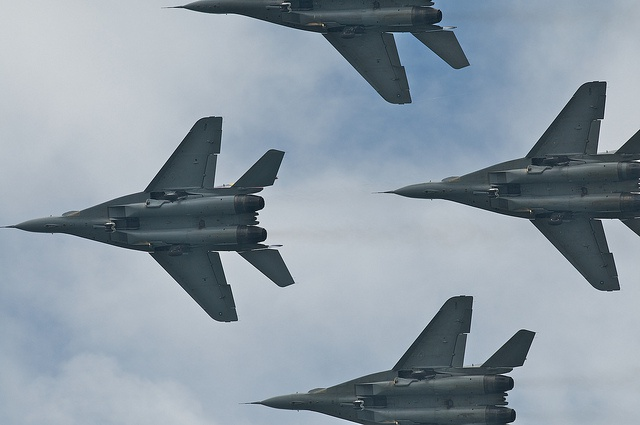Describe the objects in this image and their specific colors. I can see airplane in lightgray, purple, black, and darkblue tones, airplane in lightgray, purple, darkblue, black, and gray tones, airplane in lightgray, purple, black, and darkblue tones, and airplane in lightgray, purple, navy, and darkblue tones in this image. 